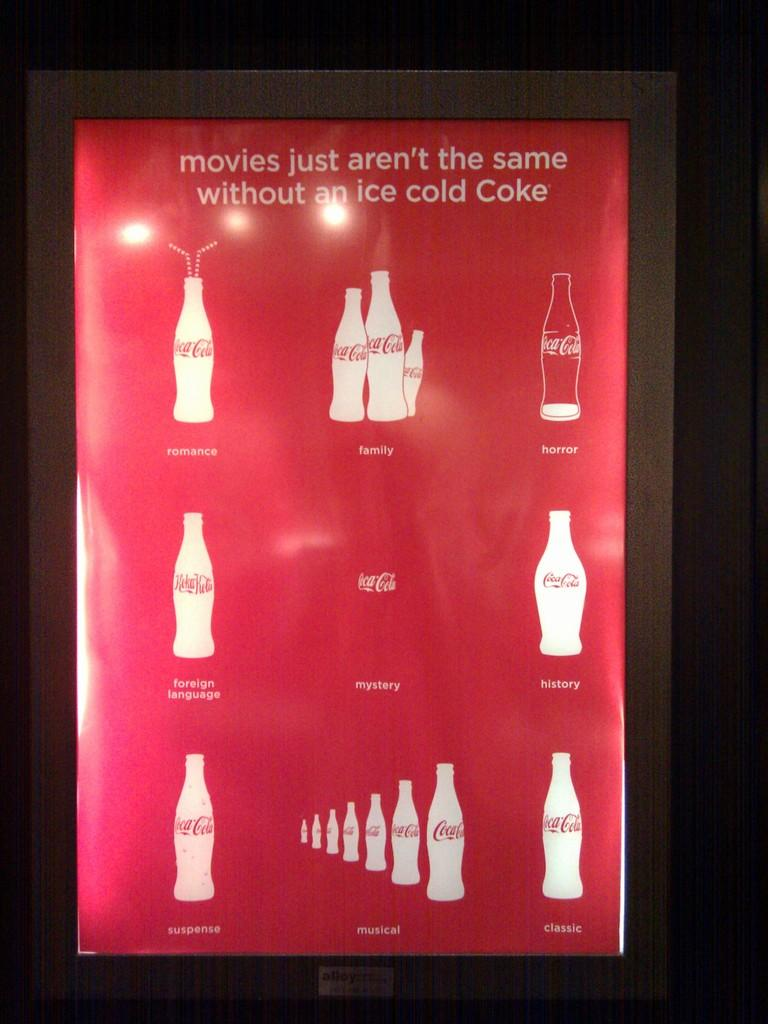Provide a one-sentence caption for the provided image. a poster for coca-cola that states that movies are not the same without an ice cold one. 